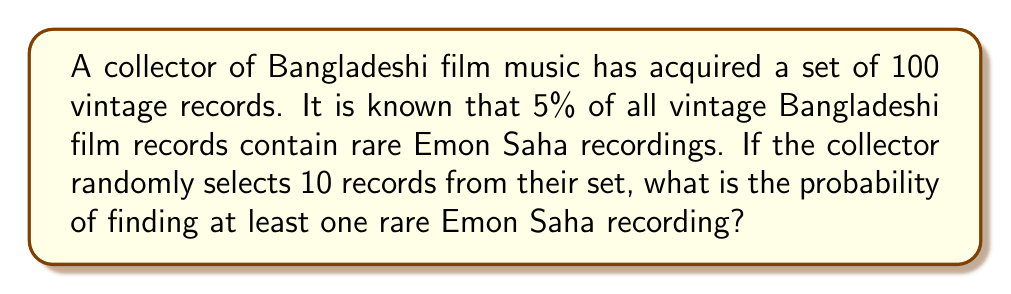Solve this math problem. Let's approach this step-by-step using the binomial probability distribution:

1) Let $p$ be the probability of a record containing a rare Emon Saha recording. We're given that $p = 0.05$.

2) Let $q$ be the probability of a record not containing a rare Emon Saha recording. Thus, $q = 1 - p = 0.95$.

3) We want to find the probability of at least one success in 10 trials. It's easier to calculate the probability of no successes and subtract from 1.

4) The probability of no rare Emon Saha recordings in 10 selections is:

   $$P(\text{no rare recordings}) = q^{10} = 0.95^{10} = 0.5987$$

5) Therefore, the probability of at least one rare Emon Saha recording is:

   $$P(\text{at least one rare recording}) = 1 - P(\text{no rare recordings})$$
   $$= 1 - 0.5987 = 0.4013$$

6) Converting to a percentage:

   $$0.4013 \times 100\% = 40.13\%$$

Thus, the probability of finding at least one rare Emon Saha recording in 10 randomly selected records is approximately 40.13%.
Answer: 40.13% 